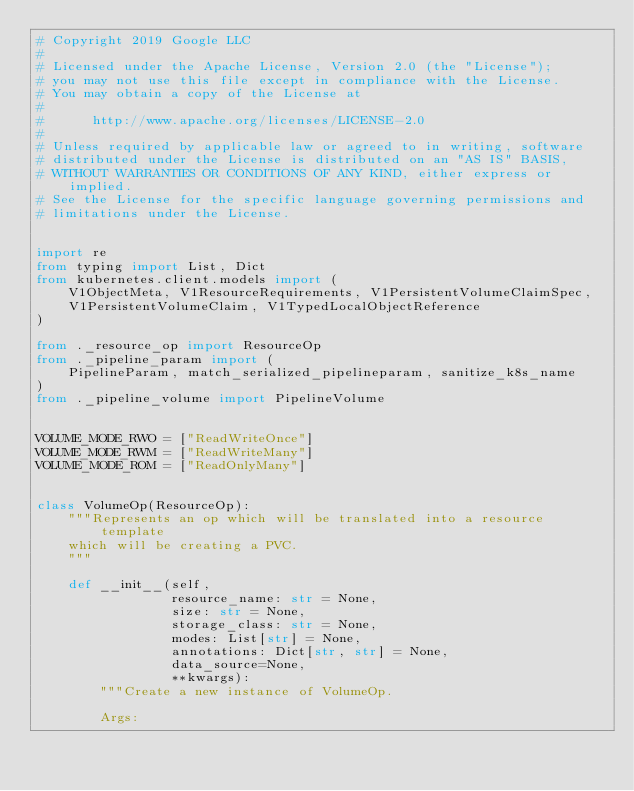Convert code to text. <code><loc_0><loc_0><loc_500><loc_500><_Python_># Copyright 2019 Google LLC
#
# Licensed under the Apache License, Version 2.0 (the "License");
# you may not use this file except in compliance with the License.
# You may obtain a copy of the License at
#
#      http://www.apache.org/licenses/LICENSE-2.0
#
# Unless required by applicable law or agreed to in writing, software
# distributed under the License is distributed on an "AS IS" BASIS,
# WITHOUT WARRANTIES OR CONDITIONS OF ANY KIND, either express or implied.
# See the License for the specific language governing permissions and
# limitations under the License.


import re
from typing import List, Dict
from kubernetes.client.models import (
    V1ObjectMeta, V1ResourceRequirements, V1PersistentVolumeClaimSpec,
    V1PersistentVolumeClaim, V1TypedLocalObjectReference
)

from ._resource_op import ResourceOp
from ._pipeline_param import (
    PipelineParam, match_serialized_pipelineparam, sanitize_k8s_name
)
from ._pipeline_volume import PipelineVolume


VOLUME_MODE_RWO = ["ReadWriteOnce"]
VOLUME_MODE_RWM = ["ReadWriteMany"]
VOLUME_MODE_ROM = ["ReadOnlyMany"]


class VolumeOp(ResourceOp):
    """Represents an op which will be translated into a resource template
    which will be creating a PVC.
    """

    def __init__(self,
                 resource_name: str = None,
                 size: str = None,
                 storage_class: str = None,
                 modes: List[str] = None,
                 annotations: Dict[str, str] = None,
                 data_source=None,
                 **kwargs):
        """Create a new instance of VolumeOp.

        Args:</code> 